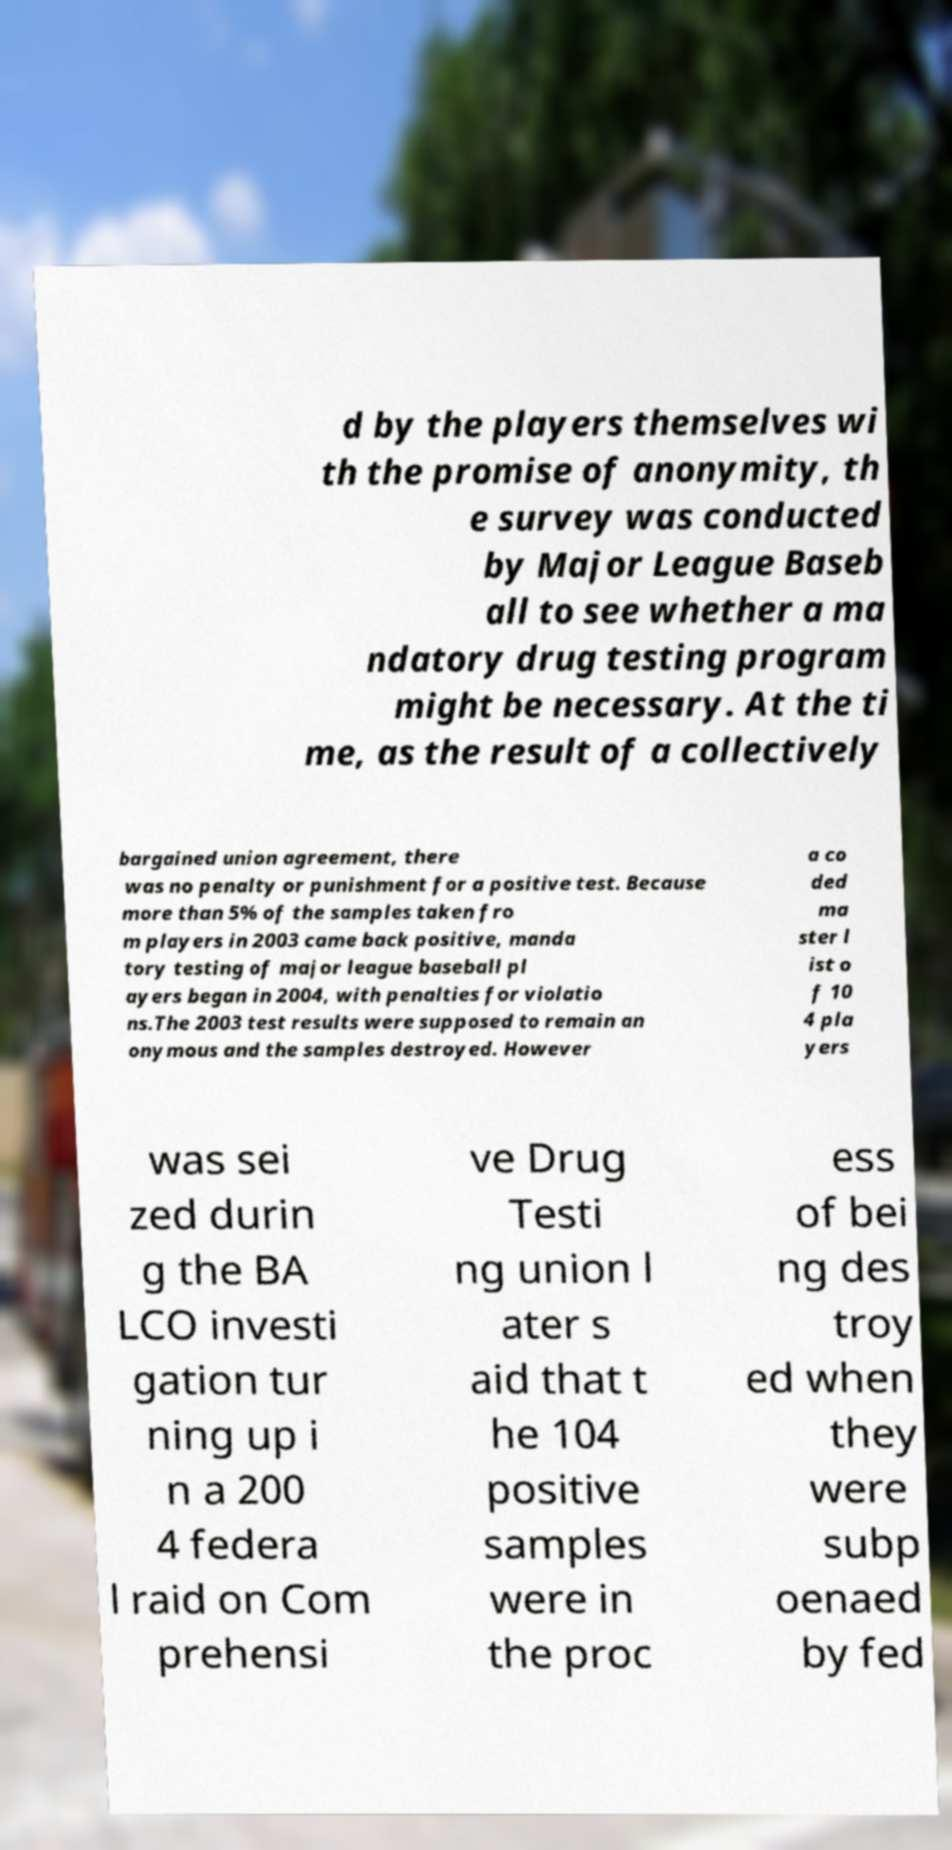Can you accurately transcribe the text from the provided image for me? d by the players themselves wi th the promise of anonymity, th e survey was conducted by Major League Baseb all to see whether a ma ndatory drug testing program might be necessary. At the ti me, as the result of a collectively bargained union agreement, there was no penalty or punishment for a positive test. Because more than 5% of the samples taken fro m players in 2003 came back positive, manda tory testing of major league baseball pl ayers began in 2004, with penalties for violatio ns.The 2003 test results were supposed to remain an onymous and the samples destroyed. However a co ded ma ster l ist o f 10 4 pla yers was sei zed durin g the BA LCO investi gation tur ning up i n a 200 4 federa l raid on Com prehensi ve Drug Testi ng union l ater s aid that t he 104 positive samples were in the proc ess of bei ng des troy ed when they were subp oenaed by fed 